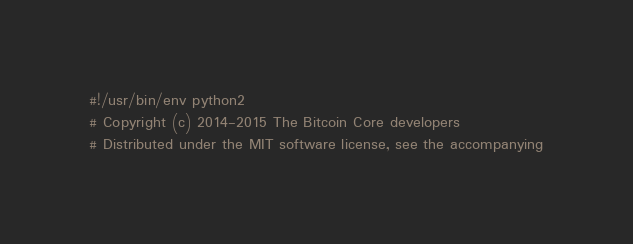<code> <loc_0><loc_0><loc_500><loc_500><_Python_>#!/usr/bin/env python2
# Copyright (c) 2014-2015 The Bitcoin Core developers
# Distributed under the MIT software license, see the accompanying</code> 